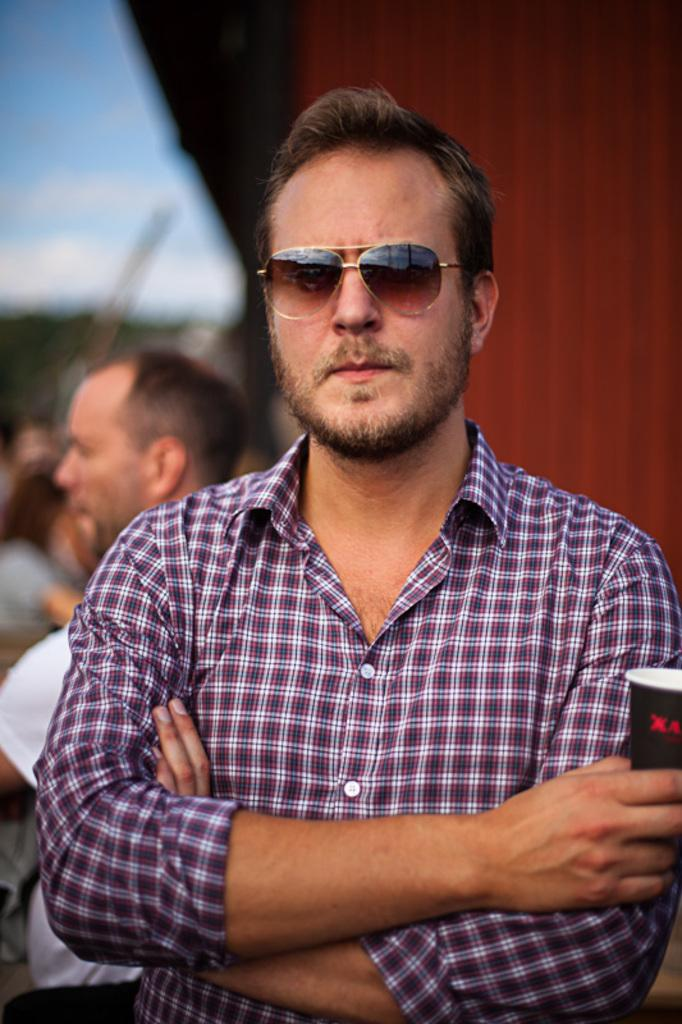What is the main subject of the image? The main subject of the image is a group of people. Can you describe the man in the middle of the image? The man in the middle of the image is wearing spectacles. What is the man holding in the image? The man is holding a cup. What type of cannon is being fired in the image? There is no cannon present in the image; it features a group of people with a man holding a cup. 